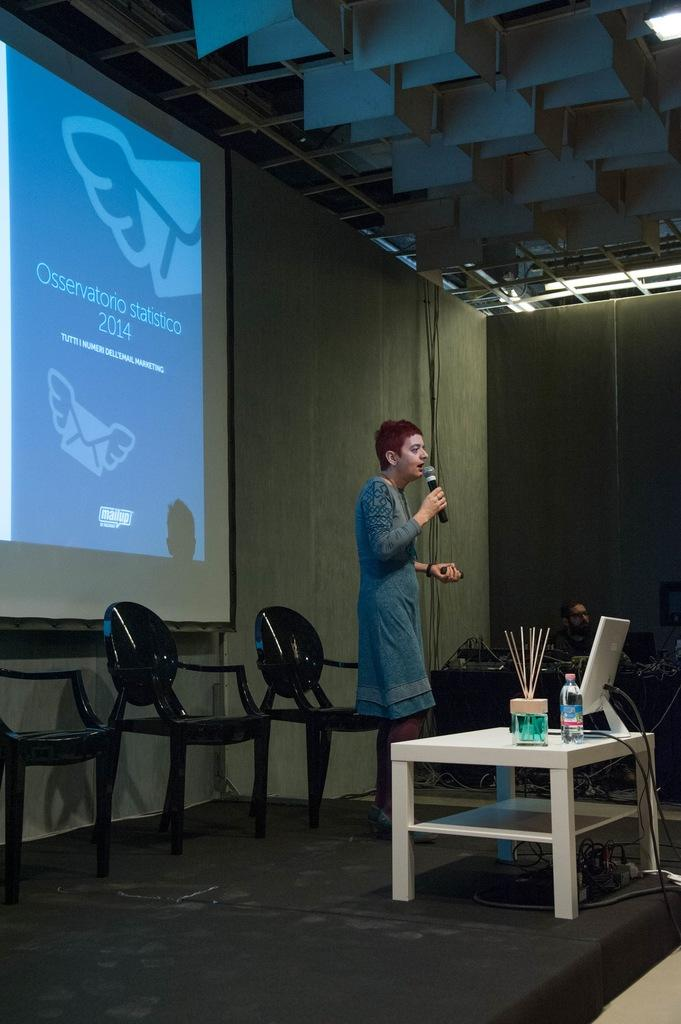<image>
Present a compact description of the photo's key features. Woman giving a speech in front of a presentation saying the year 2014. 